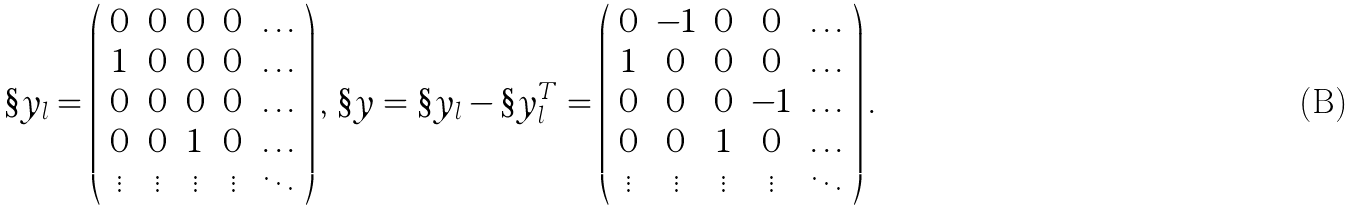<formula> <loc_0><loc_0><loc_500><loc_500>\S y _ { l } = \left ( \begin{array} { c c c c c } 0 & 0 & 0 & 0 & \dots \\ 1 & 0 & 0 & 0 & \dots \\ 0 & 0 & 0 & 0 & \dots \\ 0 & 0 & 1 & 0 & \dots \\ \vdots & \vdots & \vdots & \vdots & \ddots \end{array} \right ) , \, \S y = \S y _ { l } - \S y _ { l } ^ { T } = \left ( \begin{array} { c c c c c } 0 & - 1 & 0 & 0 & \dots \\ 1 & 0 & 0 & 0 & \dots \\ 0 & 0 & 0 & - 1 & \dots \\ 0 & 0 & 1 & 0 & \dots \\ \vdots & \vdots & \vdots & \vdots & \ddots \end{array} \right ) .</formula> 